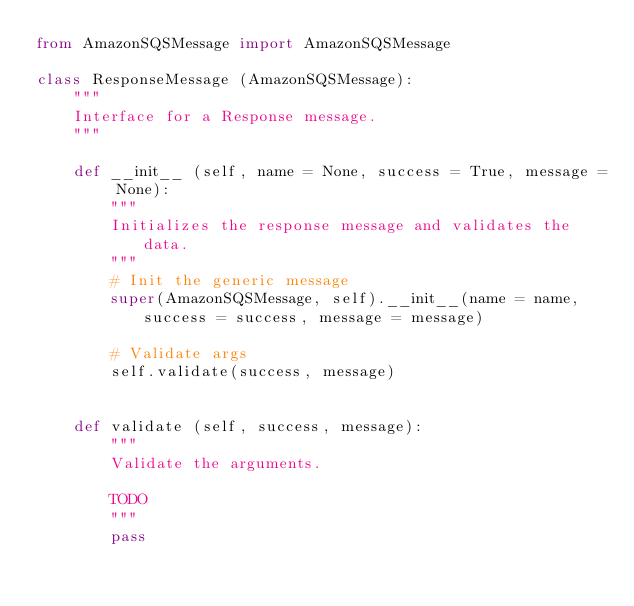Convert code to text. <code><loc_0><loc_0><loc_500><loc_500><_Python_>from AmazonSQSMessage import AmazonSQSMessage

class ResponseMessage (AmazonSQSMessage):
    """
    Interface for a Response message.
    """

    def __init__ (self, name = None, success = True, message = None):
        """
        Initializes the response message and validates the data.
        """
        # Init the generic message
        super(AmazonSQSMessage, self).__init__(name = name, success = success, message = message)

        # Validate args
        self.validate(success, message)


    def validate (self, success, message):
        """
        Validate the arguments.

        TODO
        """
        pass
</code> 